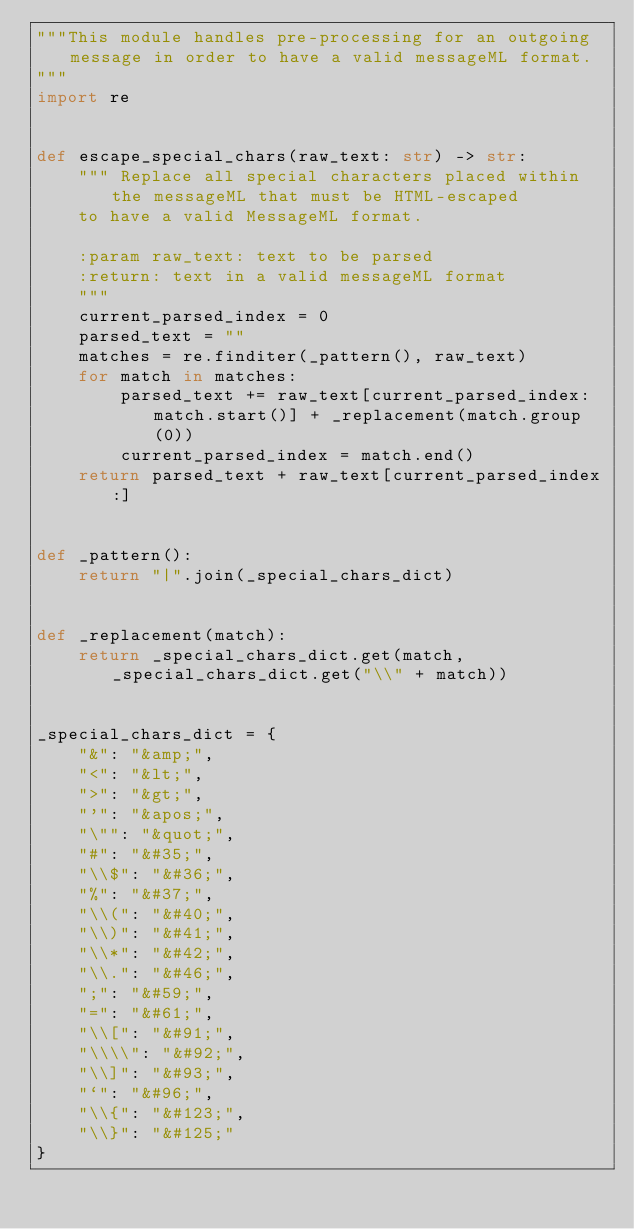<code> <loc_0><loc_0><loc_500><loc_500><_Python_>"""This module handles pre-processing for an outgoing message in order to have a valid messageML format.
"""
import re


def escape_special_chars(raw_text: str) -> str:
    """ Replace all special characters placed within the messageML that must be HTML-escaped
    to have a valid MessageML format.

    :param raw_text: text to be parsed
    :return: text in a valid messageML format
    """
    current_parsed_index = 0
    parsed_text = ""
    matches = re.finditer(_pattern(), raw_text)
    for match in matches:
        parsed_text += raw_text[current_parsed_index:match.start()] + _replacement(match.group(0))
        current_parsed_index = match.end()
    return parsed_text + raw_text[current_parsed_index:]


def _pattern():
    return "|".join(_special_chars_dict)


def _replacement(match):
    return _special_chars_dict.get(match, _special_chars_dict.get("\\" + match))


_special_chars_dict = {
    "&": "&amp;",
    "<": "&lt;",
    ">": "&gt;",
    "'": "&apos;",
    "\"": "&quot;",
    "#": "&#35;",
    "\\$": "&#36;",
    "%": "&#37;",
    "\\(": "&#40;",
    "\\)": "&#41;",
    "\\*": "&#42;",
    "\\.": "&#46;",
    ";": "&#59;",
    "=": "&#61;",
    "\\[": "&#91;",
    "\\\\": "&#92;",
    "\\]": "&#93;",
    "`": "&#96;",
    "\\{": "&#123;",
    "\\}": "&#125;"
}
</code> 